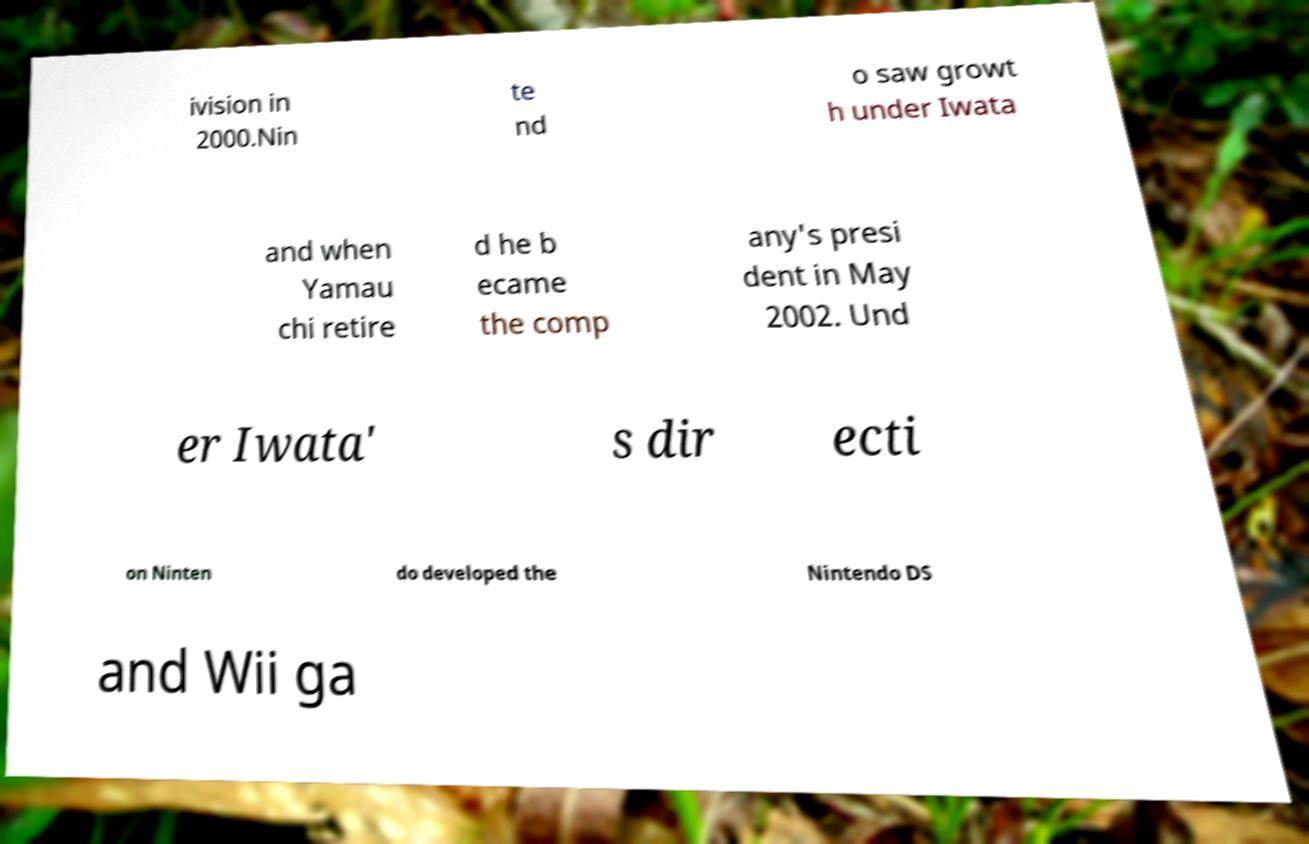Can you accurately transcribe the text from the provided image for me? ivision in 2000.Nin te nd o saw growt h under Iwata and when Yamau chi retire d he b ecame the comp any's presi dent in May 2002. Und er Iwata' s dir ecti on Ninten do developed the Nintendo DS and Wii ga 